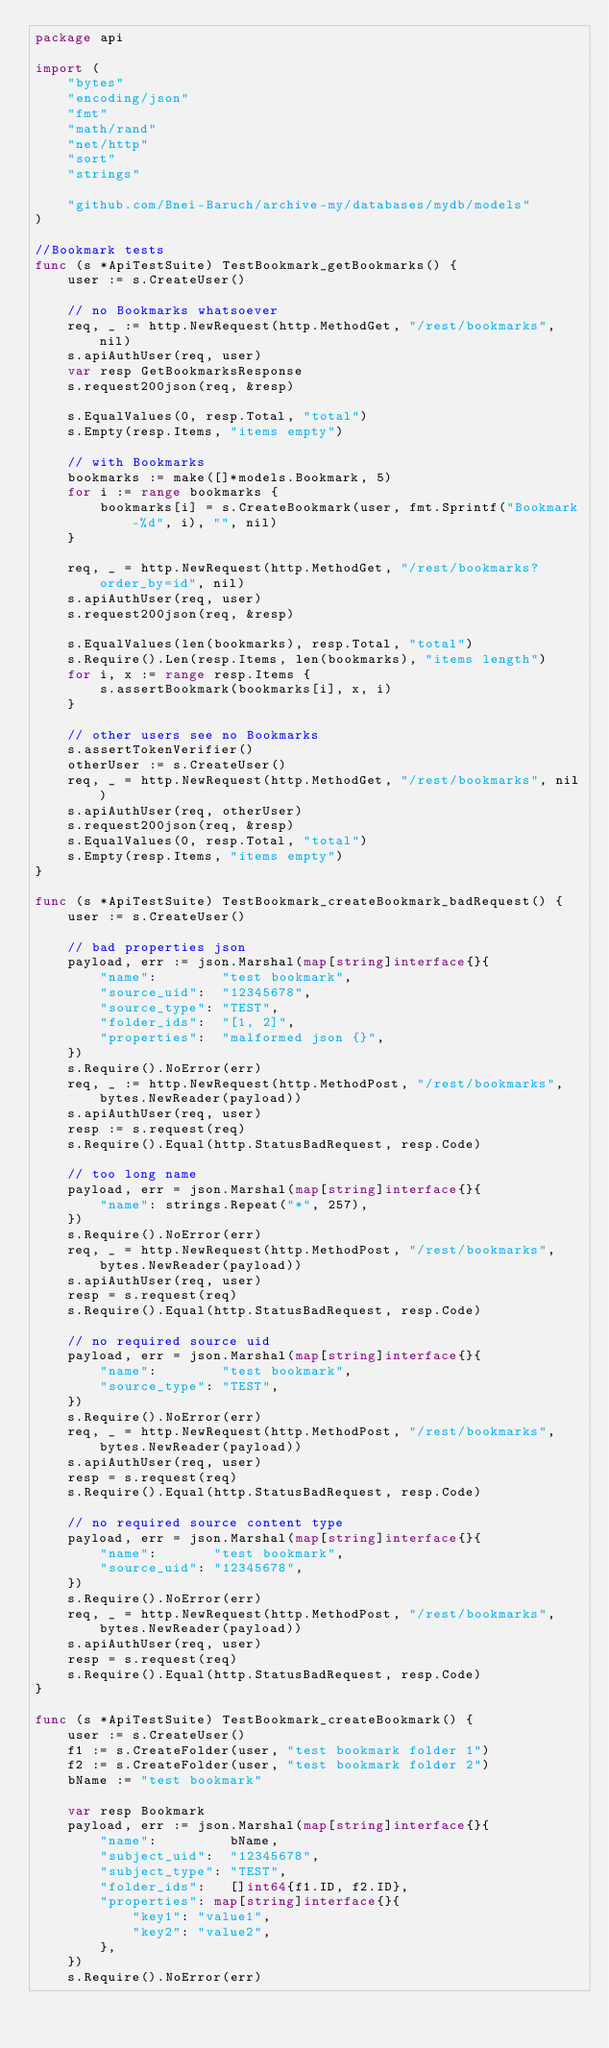Convert code to text. <code><loc_0><loc_0><loc_500><loc_500><_Go_>package api

import (
	"bytes"
	"encoding/json"
	"fmt"
	"math/rand"
	"net/http"
	"sort"
	"strings"

	"github.com/Bnei-Baruch/archive-my/databases/mydb/models"
)

//Bookmark tests
func (s *ApiTestSuite) TestBookmark_getBookmarks() {
	user := s.CreateUser()

	// no Bookmarks whatsoever
	req, _ := http.NewRequest(http.MethodGet, "/rest/bookmarks", nil)
	s.apiAuthUser(req, user)
	var resp GetBookmarksResponse
	s.request200json(req, &resp)

	s.EqualValues(0, resp.Total, "total")
	s.Empty(resp.Items, "items empty")

	// with Bookmarks
	bookmarks := make([]*models.Bookmark, 5)
	for i := range bookmarks {
		bookmarks[i] = s.CreateBookmark(user, fmt.Sprintf("Bookmark-%d", i), "", nil)
	}

	req, _ = http.NewRequest(http.MethodGet, "/rest/bookmarks?order_by=id", nil)
	s.apiAuthUser(req, user)
	s.request200json(req, &resp)

	s.EqualValues(len(bookmarks), resp.Total, "total")
	s.Require().Len(resp.Items, len(bookmarks), "items length")
	for i, x := range resp.Items {
		s.assertBookmark(bookmarks[i], x, i)
	}

	// other users see no Bookmarks
	s.assertTokenVerifier()
	otherUser := s.CreateUser()
	req, _ = http.NewRequest(http.MethodGet, "/rest/bookmarks", nil)
	s.apiAuthUser(req, otherUser)
	s.request200json(req, &resp)
	s.EqualValues(0, resp.Total, "total")
	s.Empty(resp.Items, "items empty")
}

func (s *ApiTestSuite) TestBookmark_createBookmark_badRequest() {
	user := s.CreateUser()

	// bad properties json
	payload, err := json.Marshal(map[string]interface{}{
		"name":        "test bookmark",
		"source_uid":  "12345678",
		"source_type": "TEST",
		"folder_ids":  "[1, 2]",
		"properties":  "malformed json {}",
	})
	s.Require().NoError(err)
	req, _ := http.NewRequest(http.MethodPost, "/rest/bookmarks", bytes.NewReader(payload))
	s.apiAuthUser(req, user)
	resp := s.request(req)
	s.Require().Equal(http.StatusBadRequest, resp.Code)

	// too long name
	payload, err = json.Marshal(map[string]interface{}{
		"name": strings.Repeat("*", 257),
	})
	s.Require().NoError(err)
	req, _ = http.NewRequest(http.MethodPost, "/rest/bookmarks", bytes.NewReader(payload))
	s.apiAuthUser(req, user)
	resp = s.request(req)
	s.Require().Equal(http.StatusBadRequest, resp.Code)

	// no required source uid
	payload, err = json.Marshal(map[string]interface{}{
		"name":        "test bookmark",
		"source_type": "TEST",
	})
	s.Require().NoError(err)
	req, _ = http.NewRequest(http.MethodPost, "/rest/bookmarks", bytes.NewReader(payload))
	s.apiAuthUser(req, user)
	resp = s.request(req)
	s.Require().Equal(http.StatusBadRequest, resp.Code)

	// no required source content type
	payload, err = json.Marshal(map[string]interface{}{
		"name":       "test bookmark",
		"source_uid": "12345678",
	})
	s.Require().NoError(err)
	req, _ = http.NewRequest(http.MethodPost, "/rest/bookmarks", bytes.NewReader(payload))
	s.apiAuthUser(req, user)
	resp = s.request(req)
	s.Require().Equal(http.StatusBadRequest, resp.Code)
}

func (s *ApiTestSuite) TestBookmark_createBookmark() {
	user := s.CreateUser()
	f1 := s.CreateFolder(user, "test bookmark folder 1")
	f2 := s.CreateFolder(user, "test bookmark folder 2")
	bName := "test bookmark"

	var resp Bookmark
	payload, err := json.Marshal(map[string]interface{}{
		"name":         bName,
		"subject_uid":  "12345678",
		"subject_type": "TEST",
		"folder_ids":   []int64{f1.ID, f2.ID},
		"properties": map[string]interface{}{
			"key1": "value1",
			"key2": "value2",
		},
	})
	s.Require().NoError(err)</code> 